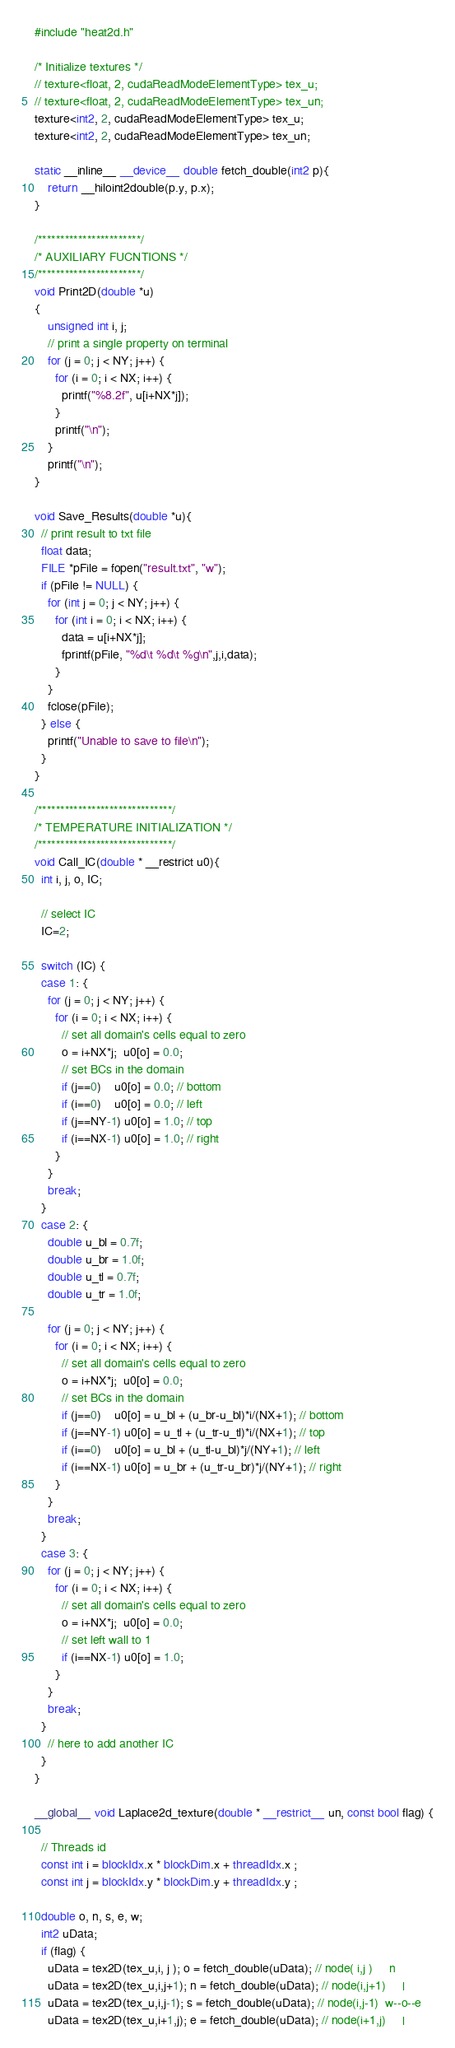Convert code to text. <code><loc_0><loc_0><loc_500><loc_500><_Cuda_>
#include "heat2d.h"

/* Initialize textures */
// texture<float, 2, cudaReadModeElementType> tex_u;
// texture<float, 2, cudaReadModeElementType> tex_un;
texture<int2, 2, cudaReadModeElementType> tex_u;
texture<int2, 2, cudaReadModeElementType> tex_un;

static __inline__ __device__ double fetch_double(int2 p){
    return __hiloint2double(p.y, p.x);
}

/***********************/
/* AUXILIARY FUCNTIONS */
/***********************/
void Print2D(double *u)
{
    unsigned int i, j;
    // print a single property on terminal
    for (j = 0; j < NY; j++) {
      for (i = 0; i < NX; i++) {
        printf("%8.2f", u[i+NX*j]);
      }
      printf("\n");
    }
    printf("\n");
}

void Save_Results(double *u){
  // print result to txt file
  float data;
  FILE *pFile = fopen("result.txt", "w");
  if (pFile != NULL) {
    for (int j = 0; j < NY; j++) {
      for (int i = 0; i < NX; i++) {      
        data = u[i+NX*j]; 
        fprintf(pFile, "%d\t %d\t %g\n",j,i,data);
      }
    }
    fclose(pFile);
  } else {
    printf("Unable to save to file\n");
  }
}

/******************************/
/* TEMPERATURE INITIALIZATION */
/******************************/
void Call_IC(double * __restrict u0){
  int i, j, o, IC; 

  // select IC
  IC=2;

  switch (IC) {
  case 1: {
    for (j = 0; j < NY; j++) {
      for (i = 0; i < NX; i++) {
        // set all domain's cells equal to zero
        o = i+NX*j;  u0[o] = 0.0;
        // set BCs in the domain 
        if (j==0)    u0[o] = 0.0; // bottom
        if (i==0)    u0[o] = 0.0; // left
        if (j==NY-1) u0[o] = 1.0; // top
        if (i==NX-1) u0[o] = 1.0; // right
      }
    }
    break;
  }
  case 2: {
    double u_bl = 0.7f;
    double u_br = 1.0f;
    double u_tl = 0.7f;
    double u_tr = 1.0f;

    for (j = 0; j < NY; j++) {
      for (i = 0; i < NX; i++) {
        // set all domain's cells equal to zero
        o = i+NX*j;  u0[o] = 0.0;
        // set BCs in the domain 
        if (j==0)    u0[o] = u_bl + (u_br-u_bl)*i/(NX+1); // bottom
        if (j==NY-1) u0[o] = u_tl + (u_tr-u_tl)*i/(NX+1); // top
        if (i==0)    u0[o] = u_bl + (u_tl-u_bl)*j/(NY+1); // left
        if (i==NX-1) u0[o] = u_br + (u_tr-u_br)*j/(NY+1); // right
      }
    }
    break;
  }
  case 3: {
    for (j = 0; j < NY; j++) {
      for (i = 0; i < NX; i++) {
        // set all domain's cells equal to zero
        o = i+NX*j;  u0[o] = 0.0;
        // set left wall to 1
        if (i==NX-1) u0[o] = 1.0;
      }
    }
    break;
  }
    // here to add another IC
  }
}

__global__ void Laplace2d_texture(double * __restrict__ un, const bool flag) {

  // Threads id
  const int i = blockIdx.x * blockDim.x + threadIdx.x ;
  const int j = blockIdx.y * blockDim.y + threadIdx.y ;  

  double o, n, s, e, w; 
  int2 uData;
  if (flag) {
    uData = tex2D(tex_u,i, j ); o = fetch_double(uData); // node( i,j )     n
    uData = tex2D(tex_u,i,j+1); n = fetch_double(uData); // node(i,j+1)     |
    uData = tex2D(tex_u,i,j-1); s = fetch_double(uData); // node(i,j-1)  w--o--e
    uData = tex2D(tex_u,i+1,j); e = fetch_double(uData); // node(i+1,j)     |</code> 